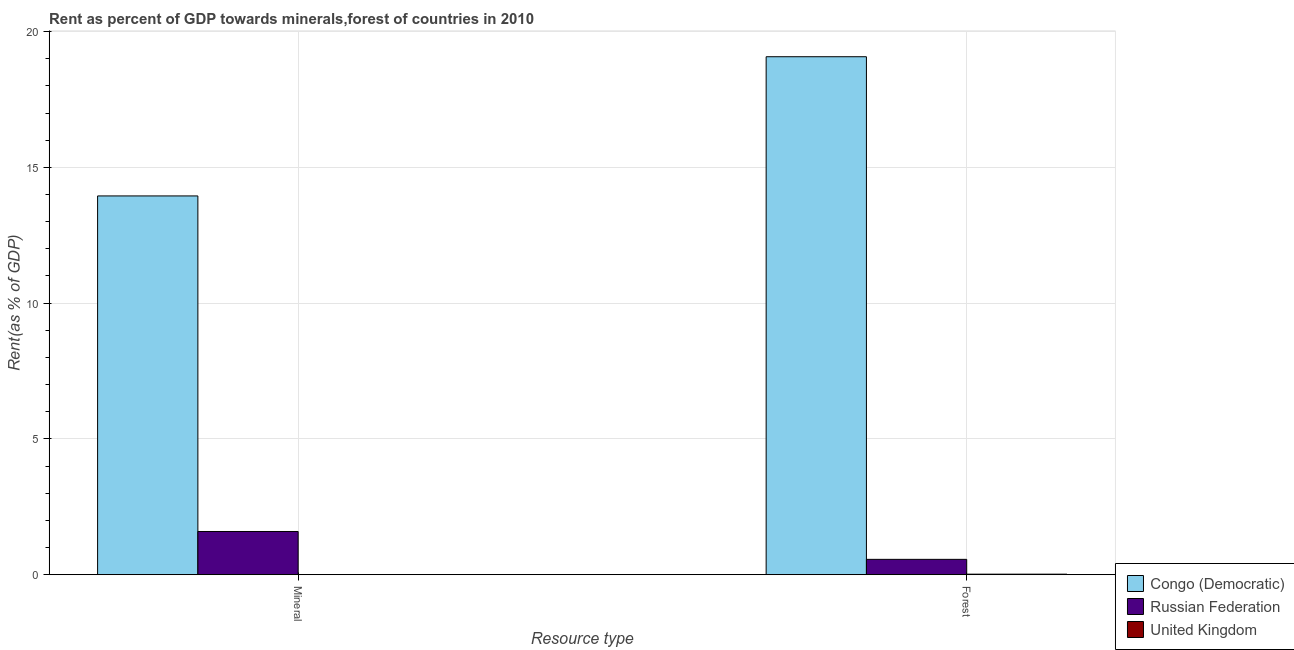How many different coloured bars are there?
Make the answer very short. 3. How many bars are there on the 2nd tick from the left?
Offer a very short reply. 3. What is the label of the 1st group of bars from the left?
Your answer should be compact. Mineral. What is the mineral rent in United Kingdom?
Ensure brevity in your answer.  0. Across all countries, what is the maximum mineral rent?
Give a very brief answer. 13.95. Across all countries, what is the minimum forest rent?
Your answer should be very brief. 0.02. In which country was the mineral rent maximum?
Provide a succinct answer. Congo (Democratic). In which country was the mineral rent minimum?
Provide a short and direct response. United Kingdom. What is the total forest rent in the graph?
Make the answer very short. 19.66. What is the difference between the forest rent in Russian Federation and that in United Kingdom?
Provide a short and direct response. 0.55. What is the difference between the forest rent in United Kingdom and the mineral rent in Congo (Democratic)?
Give a very brief answer. -13.93. What is the average forest rent per country?
Make the answer very short. 6.55. What is the difference between the forest rent and mineral rent in United Kingdom?
Your answer should be very brief. 0.02. What is the ratio of the forest rent in United Kingdom to that in Russian Federation?
Give a very brief answer. 0.03. Is the mineral rent in United Kingdom less than that in Congo (Democratic)?
Give a very brief answer. Yes. In how many countries, is the mineral rent greater than the average mineral rent taken over all countries?
Your answer should be very brief. 1. What does the 3rd bar from the left in Mineral represents?
Your answer should be compact. United Kingdom. How many bars are there?
Provide a succinct answer. 6. What is the difference between two consecutive major ticks on the Y-axis?
Your answer should be compact. 5. Are the values on the major ticks of Y-axis written in scientific E-notation?
Offer a very short reply. No. Does the graph contain any zero values?
Offer a very short reply. No. Does the graph contain grids?
Keep it short and to the point. Yes. How are the legend labels stacked?
Provide a succinct answer. Vertical. What is the title of the graph?
Provide a succinct answer. Rent as percent of GDP towards minerals,forest of countries in 2010. Does "French Polynesia" appear as one of the legend labels in the graph?
Your response must be concise. No. What is the label or title of the X-axis?
Offer a very short reply. Resource type. What is the label or title of the Y-axis?
Your response must be concise. Rent(as % of GDP). What is the Rent(as % of GDP) of Congo (Democratic) in Mineral?
Your answer should be compact. 13.95. What is the Rent(as % of GDP) of Russian Federation in Mineral?
Your answer should be very brief. 1.59. What is the Rent(as % of GDP) in United Kingdom in Mineral?
Provide a short and direct response. 0. What is the Rent(as % of GDP) of Congo (Democratic) in Forest?
Ensure brevity in your answer.  19.08. What is the Rent(as % of GDP) of Russian Federation in Forest?
Your answer should be compact. 0.56. What is the Rent(as % of GDP) in United Kingdom in Forest?
Provide a succinct answer. 0.02. Across all Resource type, what is the maximum Rent(as % of GDP) of Congo (Democratic)?
Offer a terse response. 19.08. Across all Resource type, what is the maximum Rent(as % of GDP) of Russian Federation?
Your answer should be compact. 1.59. Across all Resource type, what is the maximum Rent(as % of GDP) in United Kingdom?
Offer a very short reply. 0.02. Across all Resource type, what is the minimum Rent(as % of GDP) in Congo (Democratic)?
Your answer should be compact. 13.95. Across all Resource type, what is the minimum Rent(as % of GDP) of Russian Federation?
Keep it short and to the point. 0.56. Across all Resource type, what is the minimum Rent(as % of GDP) in United Kingdom?
Make the answer very short. 0. What is the total Rent(as % of GDP) of Congo (Democratic) in the graph?
Your answer should be compact. 33.02. What is the total Rent(as % of GDP) of Russian Federation in the graph?
Your answer should be compact. 2.16. What is the total Rent(as % of GDP) of United Kingdom in the graph?
Your answer should be very brief. 0.02. What is the difference between the Rent(as % of GDP) of Congo (Democratic) in Mineral and that in Forest?
Your answer should be very brief. -5.13. What is the difference between the Rent(as % of GDP) in Russian Federation in Mineral and that in Forest?
Offer a very short reply. 1.03. What is the difference between the Rent(as % of GDP) of United Kingdom in Mineral and that in Forest?
Make the answer very short. -0.02. What is the difference between the Rent(as % of GDP) of Congo (Democratic) in Mineral and the Rent(as % of GDP) of Russian Federation in Forest?
Offer a very short reply. 13.38. What is the difference between the Rent(as % of GDP) in Congo (Democratic) in Mineral and the Rent(as % of GDP) in United Kingdom in Forest?
Provide a succinct answer. 13.93. What is the difference between the Rent(as % of GDP) in Russian Federation in Mineral and the Rent(as % of GDP) in United Kingdom in Forest?
Ensure brevity in your answer.  1.57. What is the average Rent(as % of GDP) in Congo (Democratic) per Resource type?
Make the answer very short. 16.51. What is the average Rent(as % of GDP) in Russian Federation per Resource type?
Give a very brief answer. 1.08. What is the average Rent(as % of GDP) in United Kingdom per Resource type?
Provide a succinct answer. 0.01. What is the difference between the Rent(as % of GDP) of Congo (Democratic) and Rent(as % of GDP) of Russian Federation in Mineral?
Provide a succinct answer. 12.36. What is the difference between the Rent(as % of GDP) in Congo (Democratic) and Rent(as % of GDP) in United Kingdom in Mineral?
Keep it short and to the point. 13.95. What is the difference between the Rent(as % of GDP) of Russian Federation and Rent(as % of GDP) of United Kingdom in Mineral?
Your response must be concise. 1.59. What is the difference between the Rent(as % of GDP) in Congo (Democratic) and Rent(as % of GDP) in Russian Federation in Forest?
Keep it short and to the point. 18.51. What is the difference between the Rent(as % of GDP) in Congo (Democratic) and Rent(as % of GDP) in United Kingdom in Forest?
Give a very brief answer. 19.06. What is the difference between the Rent(as % of GDP) in Russian Federation and Rent(as % of GDP) in United Kingdom in Forest?
Ensure brevity in your answer.  0.55. What is the ratio of the Rent(as % of GDP) in Congo (Democratic) in Mineral to that in Forest?
Keep it short and to the point. 0.73. What is the ratio of the Rent(as % of GDP) in Russian Federation in Mineral to that in Forest?
Give a very brief answer. 2.82. What is the ratio of the Rent(as % of GDP) in United Kingdom in Mineral to that in Forest?
Offer a very short reply. 0.01. What is the difference between the highest and the second highest Rent(as % of GDP) in Congo (Democratic)?
Your answer should be very brief. 5.13. What is the difference between the highest and the second highest Rent(as % of GDP) in Russian Federation?
Your response must be concise. 1.03. What is the difference between the highest and the second highest Rent(as % of GDP) in United Kingdom?
Your response must be concise. 0.02. What is the difference between the highest and the lowest Rent(as % of GDP) of Congo (Democratic)?
Your answer should be compact. 5.13. What is the difference between the highest and the lowest Rent(as % of GDP) in Russian Federation?
Offer a terse response. 1.03. What is the difference between the highest and the lowest Rent(as % of GDP) in United Kingdom?
Your answer should be very brief. 0.02. 